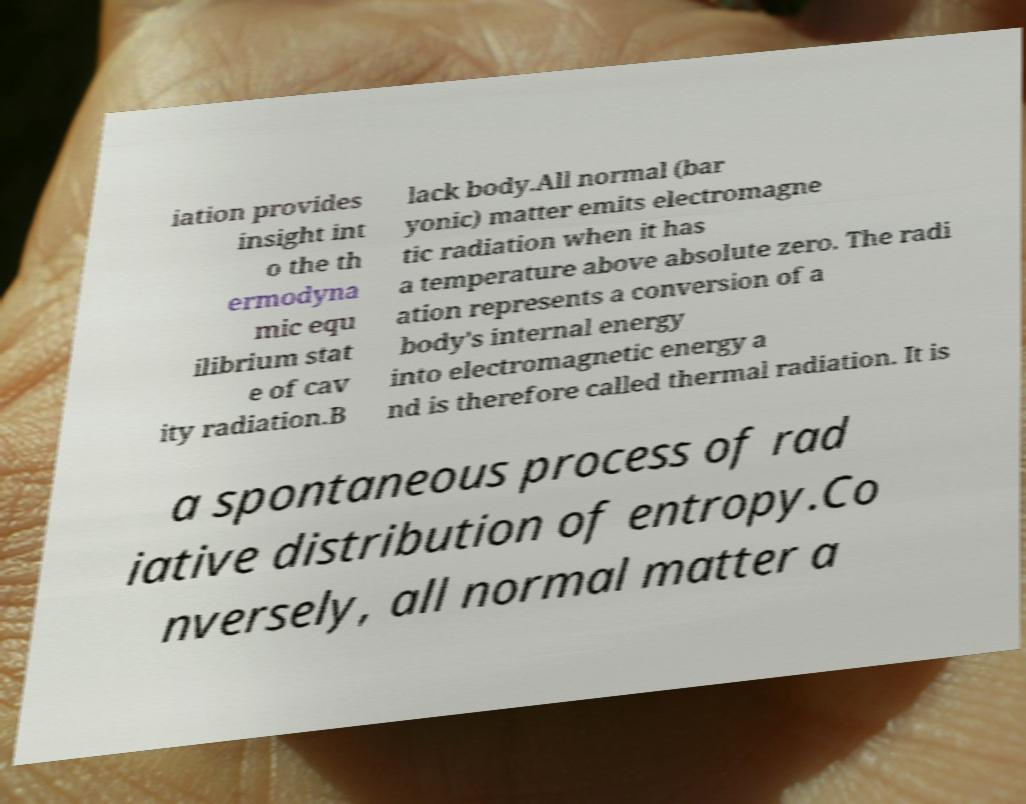Please read and relay the text visible in this image. What does it say? iation provides insight int o the th ermodyna mic equ ilibrium stat e of cav ity radiation.B lack body.All normal (bar yonic) matter emits electromagne tic radiation when it has a temperature above absolute zero. The radi ation represents a conversion of a body's internal energy into electromagnetic energy a nd is therefore called thermal radiation. It is a spontaneous process of rad iative distribution of entropy.Co nversely, all normal matter a 